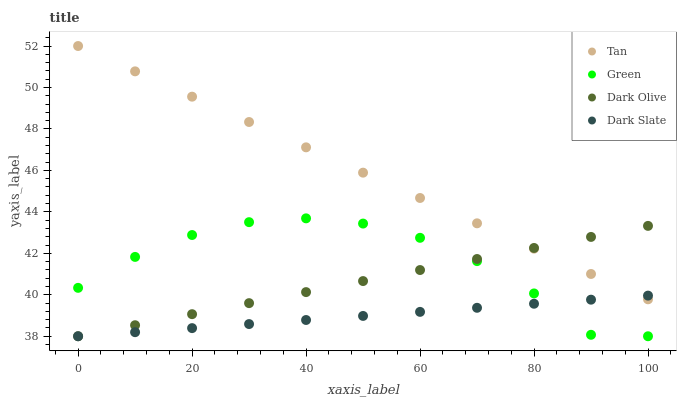Does Dark Slate have the minimum area under the curve?
Answer yes or no. Yes. Does Tan have the maximum area under the curve?
Answer yes or no. Yes. Does Dark Olive have the minimum area under the curve?
Answer yes or no. No. Does Dark Olive have the maximum area under the curve?
Answer yes or no. No. Is Dark Slate the smoothest?
Answer yes or no. Yes. Is Green the roughest?
Answer yes or no. Yes. Is Tan the smoothest?
Answer yes or no. No. Is Tan the roughest?
Answer yes or no. No. Does Dark Slate have the lowest value?
Answer yes or no. Yes. Does Tan have the lowest value?
Answer yes or no. No. Does Tan have the highest value?
Answer yes or no. Yes. Does Dark Olive have the highest value?
Answer yes or no. No. Is Green less than Tan?
Answer yes or no. Yes. Is Tan greater than Green?
Answer yes or no. Yes. Does Green intersect Dark Olive?
Answer yes or no. Yes. Is Green less than Dark Olive?
Answer yes or no. No. Is Green greater than Dark Olive?
Answer yes or no. No. Does Green intersect Tan?
Answer yes or no. No. 